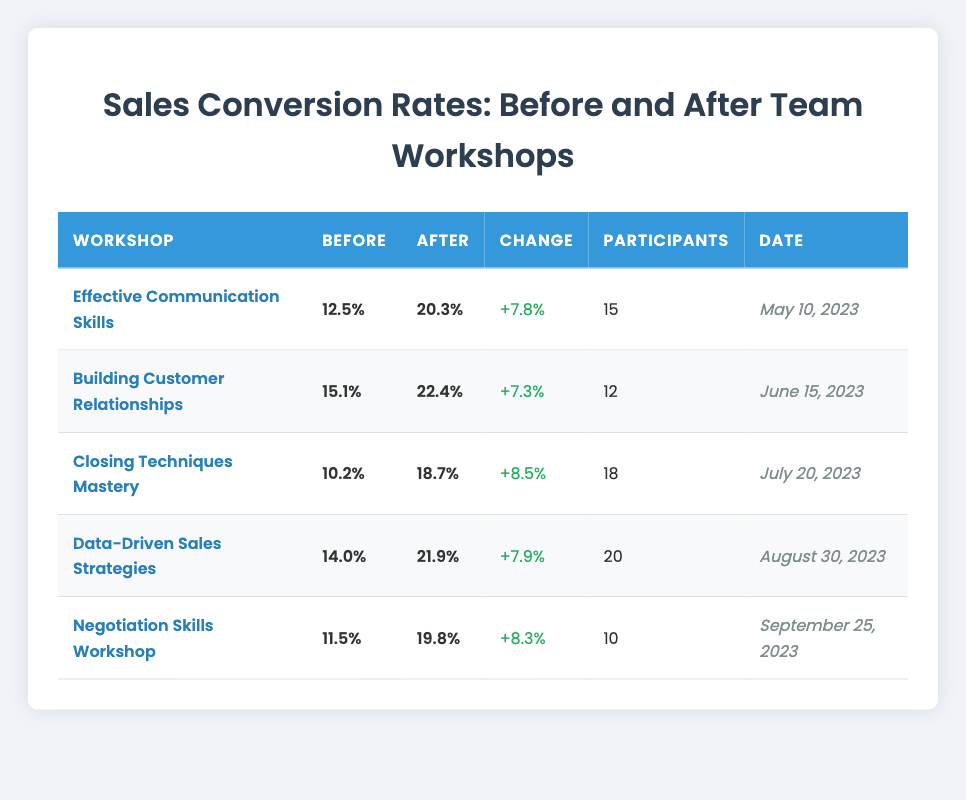What was the conversion rate after the "Data-Driven Sales Strategies" workshop? The conversion rate after the "Data-Driven Sales Strategies" workshop is found in the After column for that workshop, which shows 21.9%.
Answer: 21.9% How many participants attended the "Building Customer Relationships" workshop? To find the number of participants for this workshop, look at the Participants column next to "Building Customer Relationships," which lists 12 participants.
Answer: 12 What is the average conversion rate before the workshops? To calculate the average before conversion rate, add the before conversion rates: 12.5 + 15.1 + 10.2 + 14.0 + 11.5 = 63.3. Then divide by the number of workshops (5): 63.3 / 5 = 12.66.
Answer: 12.66 Did the "Closing Techniques Mastery" workshop have the highest increase in conversion rate? First, we calculate the change for the "Closing Techniques Mastery" workshop, which is 18.7% - 10.2% = 8.5%. Then, we check the changes for other workshops: Effective Communication Skills (7.8%), Building Customer Relationships (7.3%), Data-Driven Sales Strategies (7.9%), and Negotiation Skills (8.3%). The highest change is 8.5% from "Closing Techniques Mastery," confirming it does have the highest increase.
Answer: Yes What was the total percentage increase in conversion rates from all workshops? To find the total percentage increase, we need to sum the individual changes: 7.8% + 7.3% + 8.5% + 7.9% + 8.3% = 39.8%. This shows the overall increase across all workshops.
Answer: 39.8% Was the conversion rate before the "Negotiation Skills Workshop" lower than 12%? Looking at the table, the before conversion rate for the "Negotiation Skills Workshop" is 11.5%, which is indeed lower than 12%.
Answer: Yes Which workshop had the most participants, and what were their conversion rates before and after? The workshop with the most participants is "Data-Driven Sales Strategies," with 20 participants. The before conversion rate is 14.0%, and the after conversion rate is 21.9%.
Answer: Data-Driven Sales Strategies, Before: 14.0%, After: 21.9% Calculate the median before conversion rate of the workshops. First, list the before conversion rates in order: 10.2%, 11.5%, 12.5%, 14.0%, 15.1%. Since there are 5 values, the median is the middle one, which is 12.5%.
Answer: 12.5% 